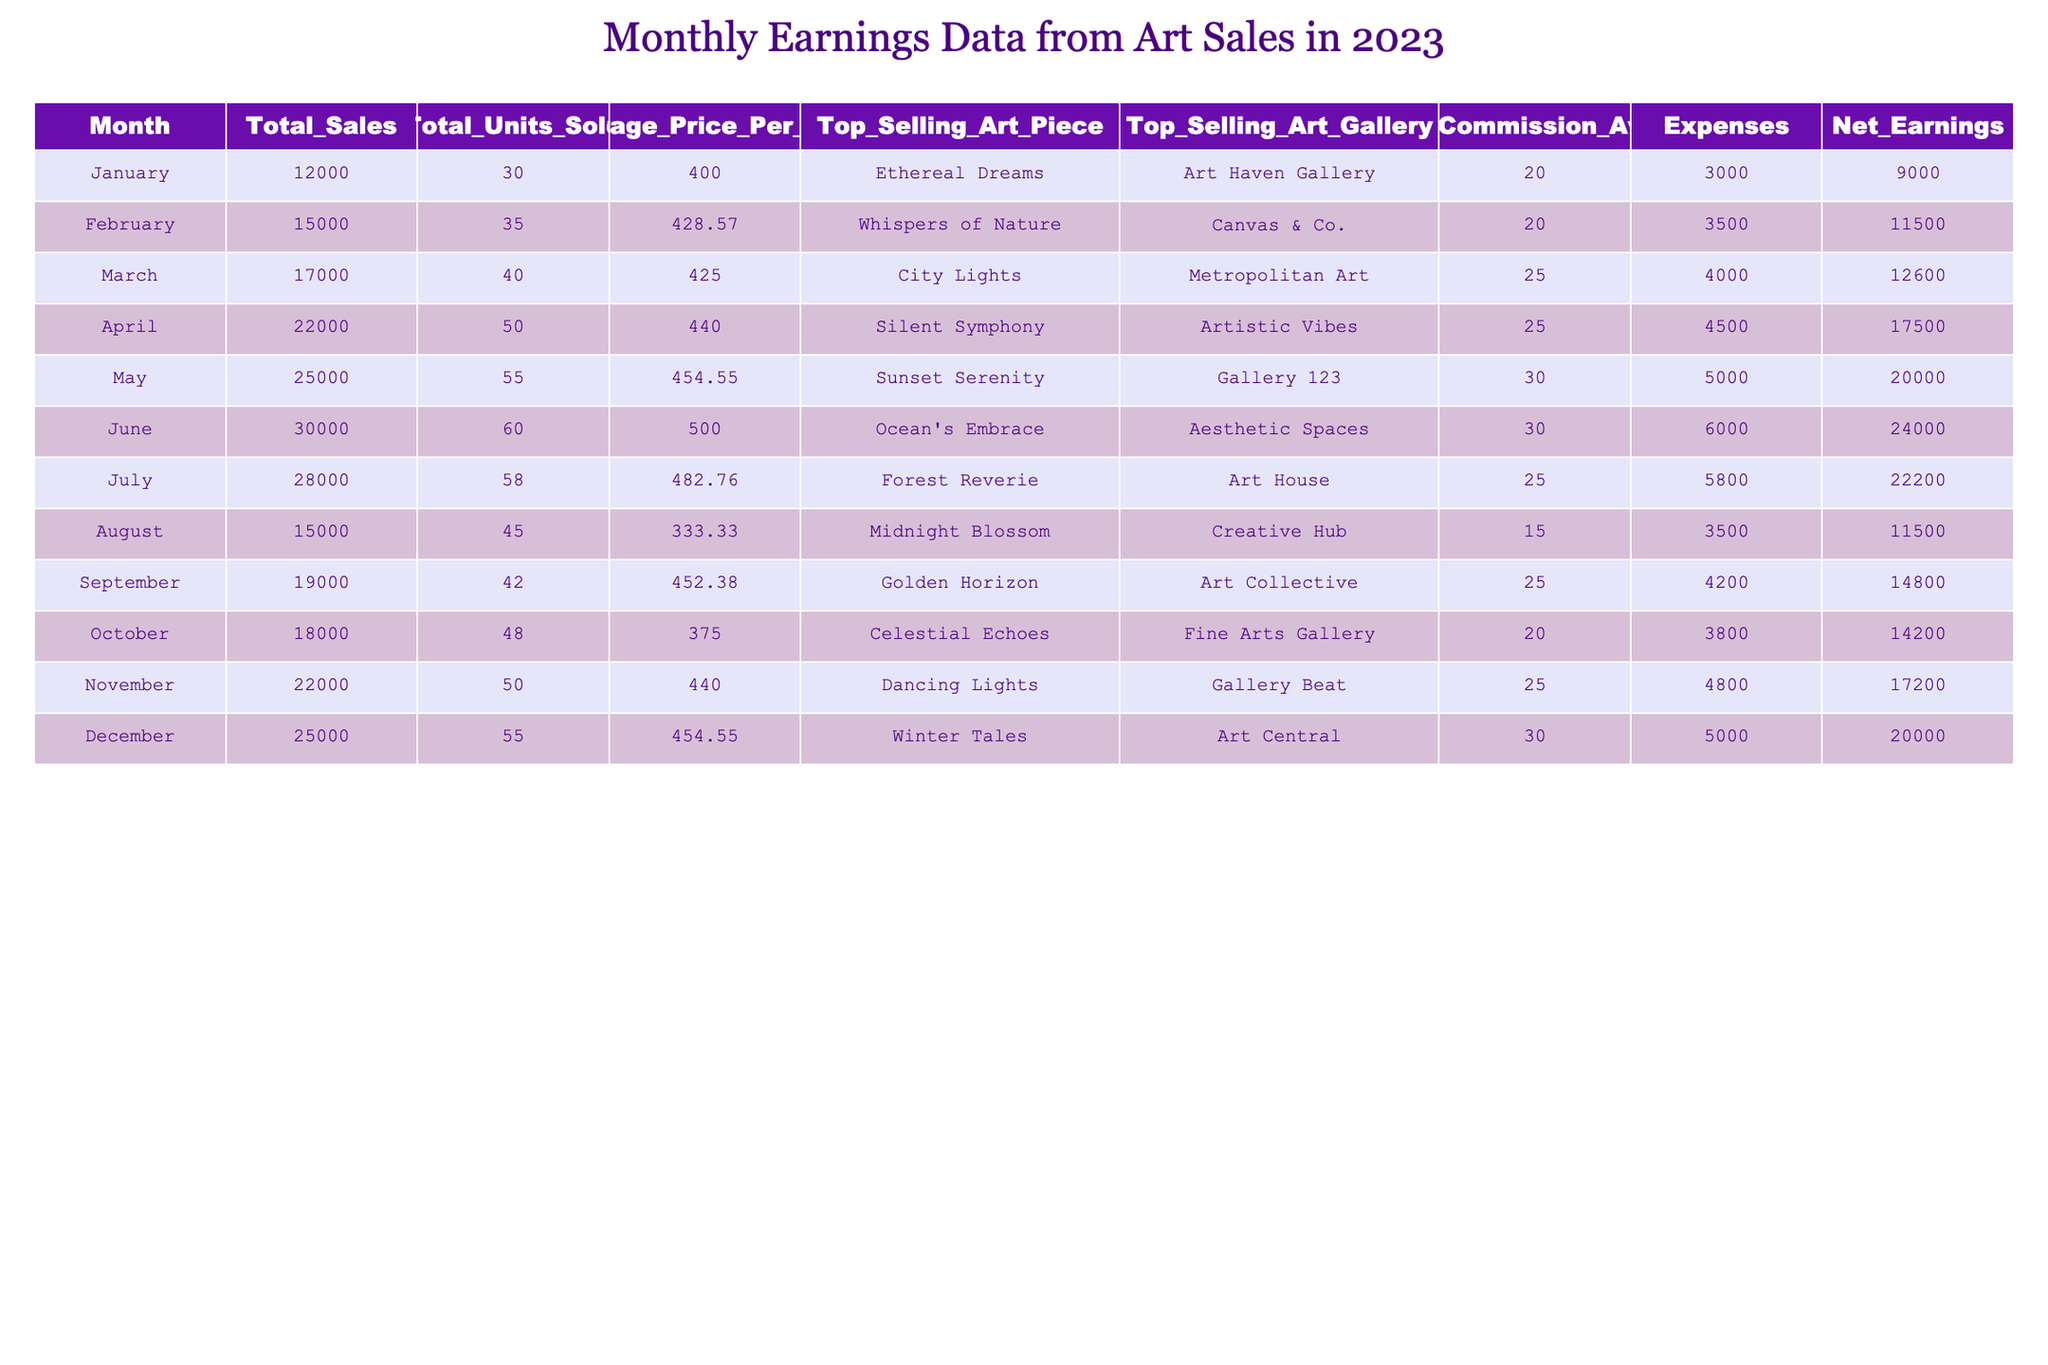What was the net earnings in June? From the table, the net earnings for June is directly listed under the "Net_Earnings" column for that month. It shows a value of 24000.
Answer: 24000 Which month had the highest total sales and what was the amount? By examining the "Total_Sales" column, June shows the highest total sales amount of 30000 among all the months listed.
Answer: 30000 What is the average price per unit sold across the year? To find the average price per unit sold, sum all the values in the "Average_Price_Per_Unit" column and divide by the number of months (12). So, (400 + 428.57 + 425 + 440 + 454.55 + 500 + 482.76 + 333.33 + 452.38 + 375 + 440 + 454.55) / 12 = 433.97.
Answer: 433.97 Did the top selling art piece change every month? Reviewing the "Top_Selling_Art_Piece" column, each month features a different piece, confirming that they all changed.
Answer: Yes What is the total net earnings for the first half of the year (January to June)? To find this, add the net earnings from January through June: 9000 + 11500 + 12600 + 17500 + 20000 + 24000 = 115600.
Answer: 115600 In which month was the artist commission average 15? The "Artist_Commission_Average" for April is 15, as seen in the corresponding column for that month.
Answer: August Which month had the highest average price per unit and what was it? Looking through the "Average_Price_Per_Unit" column, June has the highest value at 500.
Answer: 500 What is the difference in total sales between the highest and lowest months? The highest total sales were in June (30000) and the lowest in January (12000). The difference is 30000 - 12000 = 18000.
Answer: 18000 Is there a month where the total expenses were greater than the net earnings? By checking the "Expenses" versus "Net_Earnings" columns, for February (3500 vs 11500), March (4000 vs 12600), and all other months, the expenses never exceed net earnings.
Answer: No What was the total number of units sold in the second half of the year (July to December)? To find this, sum the "Total_Units_Sold" from July to December: 58 + 45 + 42 + 48 + 50 + 55 = 298.
Answer: 298 